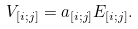<formula> <loc_0><loc_0><loc_500><loc_500>V _ { [ i ; j ] } = a _ { [ i ; j ] } E _ { [ i ; j ] } .</formula> 